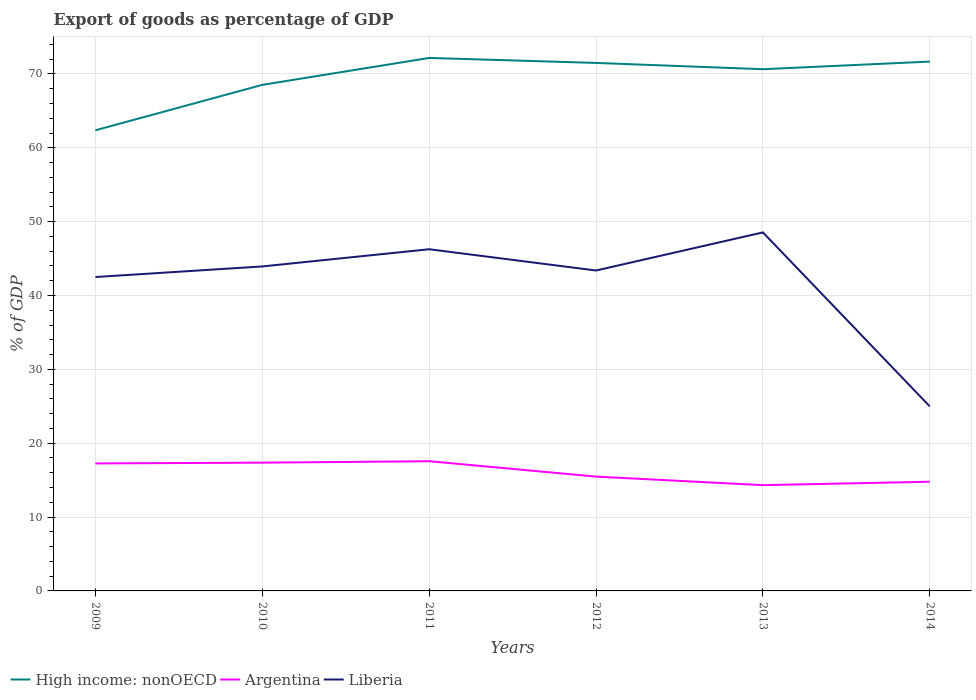How many different coloured lines are there?
Offer a terse response. 3. Is the number of lines equal to the number of legend labels?
Your response must be concise. Yes. Across all years, what is the maximum export of goods as percentage of GDP in Argentina?
Ensure brevity in your answer.  14.32. What is the total export of goods as percentage of GDP in Liberia in the graph?
Provide a succinct answer. 0.55. What is the difference between the highest and the second highest export of goods as percentage of GDP in High income: nonOECD?
Give a very brief answer. 9.8. Is the export of goods as percentage of GDP in High income: nonOECD strictly greater than the export of goods as percentage of GDP in Argentina over the years?
Make the answer very short. No. Does the graph contain grids?
Offer a very short reply. Yes. Where does the legend appear in the graph?
Make the answer very short. Bottom left. How are the legend labels stacked?
Offer a terse response. Horizontal. What is the title of the graph?
Provide a succinct answer. Export of goods as percentage of GDP. What is the label or title of the X-axis?
Your response must be concise. Years. What is the label or title of the Y-axis?
Your answer should be very brief. % of GDP. What is the % of GDP in High income: nonOECD in 2009?
Make the answer very short. 62.37. What is the % of GDP of Argentina in 2009?
Ensure brevity in your answer.  17.27. What is the % of GDP in Liberia in 2009?
Provide a succinct answer. 42.51. What is the % of GDP in High income: nonOECD in 2010?
Your answer should be compact. 68.53. What is the % of GDP in Argentina in 2010?
Ensure brevity in your answer.  17.37. What is the % of GDP of Liberia in 2010?
Keep it short and to the point. 43.94. What is the % of GDP in High income: nonOECD in 2011?
Your answer should be compact. 72.17. What is the % of GDP in Argentina in 2011?
Offer a terse response. 17.56. What is the % of GDP of Liberia in 2011?
Provide a short and direct response. 46.27. What is the % of GDP of High income: nonOECD in 2012?
Make the answer very short. 71.5. What is the % of GDP of Argentina in 2012?
Give a very brief answer. 15.48. What is the % of GDP of Liberia in 2012?
Provide a succinct answer. 43.39. What is the % of GDP of High income: nonOECD in 2013?
Give a very brief answer. 70.65. What is the % of GDP in Argentina in 2013?
Provide a succinct answer. 14.32. What is the % of GDP in Liberia in 2013?
Your answer should be very brief. 48.55. What is the % of GDP of High income: nonOECD in 2014?
Ensure brevity in your answer.  71.68. What is the % of GDP of Argentina in 2014?
Offer a very short reply. 14.79. What is the % of GDP in Liberia in 2014?
Your answer should be compact. 24.99. Across all years, what is the maximum % of GDP in High income: nonOECD?
Your response must be concise. 72.17. Across all years, what is the maximum % of GDP of Argentina?
Ensure brevity in your answer.  17.56. Across all years, what is the maximum % of GDP in Liberia?
Offer a very short reply. 48.55. Across all years, what is the minimum % of GDP of High income: nonOECD?
Give a very brief answer. 62.37. Across all years, what is the minimum % of GDP of Argentina?
Your response must be concise. 14.32. Across all years, what is the minimum % of GDP of Liberia?
Give a very brief answer. 24.99. What is the total % of GDP of High income: nonOECD in the graph?
Give a very brief answer. 416.9. What is the total % of GDP of Argentina in the graph?
Offer a very short reply. 96.79. What is the total % of GDP of Liberia in the graph?
Offer a terse response. 249.64. What is the difference between the % of GDP of High income: nonOECD in 2009 and that in 2010?
Your answer should be compact. -6.15. What is the difference between the % of GDP of Argentina in 2009 and that in 2010?
Give a very brief answer. -0.1. What is the difference between the % of GDP of Liberia in 2009 and that in 2010?
Offer a terse response. -1.43. What is the difference between the % of GDP of High income: nonOECD in 2009 and that in 2011?
Make the answer very short. -9.8. What is the difference between the % of GDP of Argentina in 2009 and that in 2011?
Provide a short and direct response. -0.3. What is the difference between the % of GDP in Liberia in 2009 and that in 2011?
Offer a terse response. -3.76. What is the difference between the % of GDP of High income: nonOECD in 2009 and that in 2012?
Offer a very short reply. -9.12. What is the difference between the % of GDP of Argentina in 2009 and that in 2012?
Offer a terse response. 1.78. What is the difference between the % of GDP in Liberia in 2009 and that in 2012?
Offer a terse response. -0.88. What is the difference between the % of GDP of High income: nonOECD in 2009 and that in 2013?
Your answer should be very brief. -8.27. What is the difference between the % of GDP of Argentina in 2009 and that in 2013?
Your response must be concise. 2.94. What is the difference between the % of GDP in Liberia in 2009 and that in 2013?
Ensure brevity in your answer.  -6.04. What is the difference between the % of GDP of High income: nonOECD in 2009 and that in 2014?
Your answer should be compact. -9.3. What is the difference between the % of GDP in Argentina in 2009 and that in 2014?
Your response must be concise. 2.48. What is the difference between the % of GDP of Liberia in 2009 and that in 2014?
Provide a short and direct response. 17.52. What is the difference between the % of GDP in High income: nonOECD in 2010 and that in 2011?
Make the answer very short. -3.65. What is the difference between the % of GDP of Argentina in 2010 and that in 2011?
Offer a terse response. -0.2. What is the difference between the % of GDP in Liberia in 2010 and that in 2011?
Your response must be concise. -2.33. What is the difference between the % of GDP in High income: nonOECD in 2010 and that in 2012?
Your response must be concise. -2.97. What is the difference between the % of GDP of Argentina in 2010 and that in 2012?
Your answer should be very brief. 1.89. What is the difference between the % of GDP of Liberia in 2010 and that in 2012?
Ensure brevity in your answer.  0.55. What is the difference between the % of GDP in High income: nonOECD in 2010 and that in 2013?
Your answer should be very brief. -2.12. What is the difference between the % of GDP in Argentina in 2010 and that in 2013?
Provide a short and direct response. 3.04. What is the difference between the % of GDP in Liberia in 2010 and that in 2013?
Give a very brief answer. -4.61. What is the difference between the % of GDP of High income: nonOECD in 2010 and that in 2014?
Offer a terse response. -3.15. What is the difference between the % of GDP in Argentina in 2010 and that in 2014?
Ensure brevity in your answer.  2.58. What is the difference between the % of GDP in Liberia in 2010 and that in 2014?
Your answer should be compact. 18.95. What is the difference between the % of GDP in High income: nonOECD in 2011 and that in 2012?
Ensure brevity in your answer.  0.67. What is the difference between the % of GDP of Argentina in 2011 and that in 2012?
Keep it short and to the point. 2.08. What is the difference between the % of GDP of Liberia in 2011 and that in 2012?
Your answer should be compact. 2.88. What is the difference between the % of GDP in High income: nonOECD in 2011 and that in 2013?
Offer a very short reply. 1.53. What is the difference between the % of GDP in Argentina in 2011 and that in 2013?
Ensure brevity in your answer.  3.24. What is the difference between the % of GDP in Liberia in 2011 and that in 2013?
Make the answer very short. -2.28. What is the difference between the % of GDP of High income: nonOECD in 2011 and that in 2014?
Your response must be concise. 0.5. What is the difference between the % of GDP of Argentina in 2011 and that in 2014?
Keep it short and to the point. 2.78. What is the difference between the % of GDP in Liberia in 2011 and that in 2014?
Your answer should be compact. 21.28. What is the difference between the % of GDP of High income: nonOECD in 2012 and that in 2013?
Offer a terse response. 0.85. What is the difference between the % of GDP in Argentina in 2012 and that in 2013?
Your answer should be very brief. 1.16. What is the difference between the % of GDP of Liberia in 2012 and that in 2013?
Make the answer very short. -5.16. What is the difference between the % of GDP in High income: nonOECD in 2012 and that in 2014?
Give a very brief answer. -0.18. What is the difference between the % of GDP of Argentina in 2012 and that in 2014?
Your answer should be compact. 0.69. What is the difference between the % of GDP of Liberia in 2012 and that in 2014?
Make the answer very short. 18.4. What is the difference between the % of GDP in High income: nonOECD in 2013 and that in 2014?
Your answer should be compact. -1.03. What is the difference between the % of GDP in Argentina in 2013 and that in 2014?
Provide a short and direct response. -0.46. What is the difference between the % of GDP of Liberia in 2013 and that in 2014?
Offer a very short reply. 23.56. What is the difference between the % of GDP of High income: nonOECD in 2009 and the % of GDP of Argentina in 2010?
Make the answer very short. 45.01. What is the difference between the % of GDP in High income: nonOECD in 2009 and the % of GDP in Liberia in 2010?
Make the answer very short. 18.44. What is the difference between the % of GDP of Argentina in 2009 and the % of GDP of Liberia in 2010?
Offer a very short reply. -26.67. What is the difference between the % of GDP of High income: nonOECD in 2009 and the % of GDP of Argentina in 2011?
Provide a succinct answer. 44.81. What is the difference between the % of GDP in High income: nonOECD in 2009 and the % of GDP in Liberia in 2011?
Keep it short and to the point. 16.11. What is the difference between the % of GDP of Argentina in 2009 and the % of GDP of Liberia in 2011?
Provide a succinct answer. -29. What is the difference between the % of GDP in High income: nonOECD in 2009 and the % of GDP in Argentina in 2012?
Ensure brevity in your answer.  46.89. What is the difference between the % of GDP in High income: nonOECD in 2009 and the % of GDP in Liberia in 2012?
Your answer should be compact. 18.99. What is the difference between the % of GDP of Argentina in 2009 and the % of GDP of Liberia in 2012?
Your answer should be very brief. -26.12. What is the difference between the % of GDP in High income: nonOECD in 2009 and the % of GDP in Argentina in 2013?
Your response must be concise. 48.05. What is the difference between the % of GDP of High income: nonOECD in 2009 and the % of GDP of Liberia in 2013?
Ensure brevity in your answer.  13.83. What is the difference between the % of GDP in Argentina in 2009 and the % of GDP in Liberia in 2013?
Give a very brief answer. -31.28. What is the difference between the % of GDP of High income: nonOECD in 2009 and the % of GDP of Argentina in 2014?
Offer a very short reply. 47.59. What is the difference between the % of GDP in High income: nonOECD in 2009 and the % of GDP in Liberia in 2014?
Give a very brief answer. 37.39. What is the difference between the % of GDP in Argentina in 2009 and the % of GDP in Liberia in 2014?
Make the answer very short. -7.72. What is the difference between the % of GDP in High income: nonOECD in 2010 and the % of GDP in Argentina in 2011?
Provide a succinct answer. 50.96. What is the difference between the % of GDP in High income: nonOECD in 2010 and the % of GDP in Liberia in 2011?
Make the answer very short. 22.26. What is the difference between the % of GDP of Argentina in 2010 and the % of GDP of Liberia in 2011?
Provide a succinct answer. -28.9. What is the difference between the % of GDP in High income: nonOECD in 2010 and the % of GDP in Argentina in 2012?
Make the answer very short. 53.05. What is the difference between the % of GDP of High income: nonOECD in 2010 and the % of GDP of Liberia in 2012?
Offer a terse response. 25.14. What is the difference between the % of GDP of Argentina in 2010 and the % of GDP of Liberia in 2012?
Provide a succinct answer. -26.02. What is the difference between the % of GDP in High income: nonOECD in 2010 and the % of GDP in Argentina in 2013?
Ensure brevity in your answer.  54.2. What is the difference between the % of GDP in High income: nonOECD in 2010 and the % of GDP in Liberia in 2013?
Your answer should be very brief. 19.98. What is the difference between the % of GDP of Argentina in 2010 and the % of GDP of Liberia in 2013?
Give a very brief answer. -31.18. What is the difference between the % of GDP of High income: nonOECD in 2010 and the % of GDP of Argentina in 2014?
Give a very brief answer. 53.74. What is the difference between the % of GDP in High income: nonOECD in 2010 and the % of GDP in Liberia in 2014?
Provide a short and direct response. 43.54. What is the difference between the % of GDP in Argentina in 2010 and the % of GDP in Liberia in 2014?
Provide a succinct answer. -7.62. What is the difference between the % of GDP in High income: nonOECD in 2011 and the % of GDP in Argentina in 2012?
Ensure brevity in your answer.  56.69. What is the difference between the % of GDP of High income: nonOECD in 2011 and the % of GDP of Liberia in 2012?
Offer a terse response. 28.78. What is the difference between the % of GDP of Argentina in 2011 and the % of GDP of Liberia in 2012?
Give a very brief answer. -25.82. What is the difference between the % of GDP of High income: nonOECD in 2011 and the % of GDP of Argentina in 2013?
Provide a short and direct response. 57.85. What is the difference between the % of GDP in High income: nonOECD in 2011 and the % of GDP in Liberia in 2013?
Offer a very short reply. 23.62. What is the difference between the % of GDP in Argentina in 2011 and the % of GDP in Liberia in 2013?
Your answer should be compact. -30.98. What is the difference between the % of GDP of High income: nonOECD in 2011 and the % of GDP of Argentina in 2014?
Make the answer very short. 57.39. What is the difference between the % of GDP in High income: nonOECD in 2011 and the % of GDP in Liberia in 2014?
Your answer should be compact. 47.18. What is the difference between the % of GDP of Argentina in 2011 and the % of GDP of Liberia in 2014?
Give a very brief answer. -7.42. What is the difference between the % of GDP in High income: nonOECD in 2012 and the % of GDP in Argentina in 2013?
Your response must be concise. 57.17. What is the difference between the % of GDP in High income: nonOECD in 2012 and the % of GDP in Liberia in 2013?
Keep it short and to the point. 22.95. What is the difference between the % of GDP of Argentina in 2012 and the % of GDP of Liberia in 2013?
Offer a terse response. -33.07. What is the difference between the % of GDP in High income: nonOECD in 2012 and the % of GDP in Argentina in 2014?
Provide a succinct answer. 56.71. What is the difference between the % of GDP of High income: nonOECD in 2012 and the % of GDP of Liberia in 2014?
Offer a terse response. 46.51. What is the difference between the % of GDP in Argentina in 2012 and the % of GDP in Liberia in 2014?
Offer a terse response. -9.51. What is the difference between the % of GDP of High income: nonOECD in 2013 and the % of GDP of Argentina in 2014?
Provide a short and direct response. 55.86. What is the difference between the % of GDP of High income: nonOECD in 2013 and the % of GDP of Liberia in 2014?
Provide a short and direct response. 45.66. What is the difference between the % of GDP of Argentina in 2013 and the % of GDP of Liberia in 2014?
Offer a very short reply. -10.66. What is the average % of GDP in High income: nonOECD per year?
Keep it short and to the point. 69.48. What is the average % of GDP of Argentina per year?
Your response must be concise. 16.13. What is the average % of GDP of Liberia per year?
Ensure brevity in your answer.  41.61. In the year 2009, what is the difference between the % of GDP of High income: nonOECD and % of GDP of Argentina?
Give a very brief answer. 45.11. In the year 2009, what is the difference between the % of GDP of High income: nonOECD and % of GDP of Liberia?
Your answer should be very brief. 19.87. In the year 2009, what is the difference between the % of GDP in Argentina and % of GDP in Liberia?
Make the answer very short. -25.24. In the year 2010, what is the difference between the % of GDP in High income: nonOECD and % of GDP in Argentina?
Your response must be concise. 51.16. In the year 2010, what is the difference between the % of GDP of High income: nonOECD and % of GDP of Liberia?
Your answer should be very brief. 24.59. In the year 2010, what is the difference between the % of GDP in Argentina and % of GDP in Liberia?
Give a very brief answer. -26.57. In the year 2011, what is the difference between the % of GDP in High income: nonOECD and % of GDP in Argentina?
Offer a terse response. 54.61. In the year 2011, what is the difference between the % of GDP of High income: nonOECD and % of GDP of Liberia?
Offer a terse response. 25.91. In the year 2011, what is the difference between the % of GDP in Argentina and % of GDP in Liberia?
Your answer should be compact. -28.7. In the year 2012, what is the difference between the % of GDP in High income: nonOECD and % of GDP in Argentina?
Ensure brevity in your answer.  56.02. In the year 2012, what is the difference between the % of GDP in High income: nonOECD and % of GDP in Liberia?
Offer a terse response. 28.11. In the year 2012, what is the difference between the % of GDP in Argentina and % of GDP in Liberia?
Your answer should be very brief. -27.91. In the year 2013, what is the difference between the % of GDP of High income: nonOECD and % of GDP of Argentina?
Ensure brevity in your answer.  56.32. In the year 2013, what is the difference between the % of GDP of High income: nonOECD and % of GDP of Liberia?
Make the answer very short. 22.1. In the year 2013, what is the difference between the % of GDP of Argentina and % of GDP of Liberia?
Ensure brevity in your answer.  -34.22. In the year 2014, what is the difference between the % of GDP in High income: nonOECD and % of GDP in Argentina?
Your answer should be very brief. 56.89. In the year 2014, what is the difference between the % of GDP of High income: nonOECD and % of GDP of Liberia?
Offer a very short reply. 46.69. In the year 2014, what is the difference between the % of GDP in Argentina and % of GDP in Liberia?
Keep it short and to the point. -10.2. What is the ratio of the % of GDP in High income: nonOECD in 2009 to that in 2010?
Your response must be concise. 0.91. What is the ratio of the % of GDP of Argentina in 2009 to that in 2010?
Your response must be concise. 0.99. What is the ratio of the % of GDP in Liberia in 2009 to that in 2010?
Provide a succinct answer. 0.97. What is the ratio of the % of GDP of High income: nonOECD in 2009 to that in 2011?
Offer a very short reply. 0.86. What is the ratio of the % of GDP in Argentina in 2009 to that in 2011?
Ensure brevity in your answer.  0.98. What is the ratio of the % of GDP in Liberia in 2009 to that in 2011?
Give a very brief answer. 0.92. What is the ratio of the % of GDP in High income: nonOECD in 2009 to that in 2012?
Provide a short and direct response. 0.87. What is the ratio of the % of GDP in Argentina in 2009 to that in 2012?
Make the answer very short. 1.12. What is the ratio of the % of GDP in Liberia in 2009 to that in 2012?
Make the answer very short. 0.98. What is the ratio of the % of GDP of High income: nonOECD in 2009 to that in 2013?
Ensure brevity in your answer.  0.88. What is the ratio of the % of GDP in Argentina in 2009 to that in 2013?
Provide a short and direct response. 1.21. What is the ratio of the % of GDP of Liberia in 2009 to that in 2013?
Your answer should be compact. 0.88. What is the ratio of the % of GDP of High income: nonOECD in 2009 to that in 2014?
Provide a succinct answer. 0.87. What is the ratio of the % of GDP in Argentina in 2009 to that in 2014?
Provide a short and direct response. 1.17. What is the ratio of the % of GDP in Liberia in 2009 to that in 2014?
Provide a short and direct response. 1.7. What is the ratio of the % of GDP in High income: nonOECD in 2010 to that in 2011?
Keep it short and to the point. 0.95. What is the ratio of the % of GDP of Liberia in 2010 to that in 2011?
Ensure brevity in your answer.  0.95. What is the ratio of the % of GDP in High income: nonOECD in 2010 to that in 2012?
Ensure brevity in your answer.  0.96. What is the ratio of the % of GDP in Argentina in 2010 to that in 2012?
Give a very brief answer. 1.12. What is the ratio of the % of GDP in Liberia in 2010 to that in 2012?
Your answer should be very brief. 1.01. What is the ratio of the % of GDP of Argentina in 2010 to that in 2013?
Offer a terse response. 1.21. What is the ratio of the % of GDP in Liberia in 2010 to that in 2013?
Keep it short and to the point. 0.91. What is the ratio of the % of GDP in High income: nonOECD in 2010 to that in 2014?
Offer a terse response. 0.96. What is the ratio of the % of GDP of Argentina in 2010 to that in 2014?
Give a very brief answer. 1.17. What is the ratio of the % of GDP in Liberia in 2010 to that in 2014?
Ensure brevity in your answer.  1.76. What is the ratio of the % of GDP in High income: nonOECD in 2011 to that in 2012?
Give a very brief answer. 1.01. What is the ratio of the % of GDP of Argentina in 2011 to that in 2012?
Your answer should be compact. 1.13. What is the ratio of the % of GDP of Liberia in 2011 to that in 2012?
Make the answer very short. 1.07. What is the ratio of the % of GDP of High income: nonOECD in 2011 to that in 2013?
Your answer should be compact. 1.02. What is the ratio of the % of GDP in Argentina in 2011 to that in 2013?
Your response must be concise. 1.23. What is the ratio of the % of GDP in Liberia in 2011 to that in 2013?
Keep it short and to the point. 0.95. What is the ratio of the % of GDP in Argentina in 2011 to that in 2014?
Make the answer very short. 1.19. What is the ratio of the % of GDP in Liberia in 2011 to that in 2014?
Your response must be concise. 1.85. What is the ratio of the % of GDP of Argentina in 2012 to that in 2013?
Provide a short and direct response. 1.08. What is the ratio of the % of GDP in Liberia in 2012 to that in 2013?
Ensure brevity in your answer.  0.89. What is the ratio of the % of GDP of Argentina in 2012 to that in 2014?
Make the answer very short. 1.05. What is the ratio of the % of GDP of Liberia in 2012 to that in 2014?
Keep it short and to the point. 1.74. What is the ratio of the % of GDP of High income: nonOECD in 2013 to that in 2014?
Keep it short and to the point. 0.99. What is the ratio of the % of GDP in Argentina in 2013 to that in 2014?
Give a very brief answer. 0.97. What is the ratio of the % of GDP in Liberia in 2013 to that in 2014?
Ensure brevity in your answer.  1.94. What is the difference between the highest and the second highest % of GDP in High income: nonOECD?
Provide a succinct answer. 0.5. What is the difference between the highest and the second highest % of GDP in Argentina?
Make the answer very short. 0.2. What is the difference between the highest and the second highest % of GDP in Liberia?
Your answer should be very brief. 2.28. What is the difference between the highest and the lowest % of GDP of High income: nonOECD?
Give a very brief answer. 9.8. What is the difference between the highest and the lowest % of GDP in Argentina?
Provide a short and direct response. 3.24. What is the difference between the highest and the lowest % of GDP in Liberia?
Offer a terse response. 23.56. 